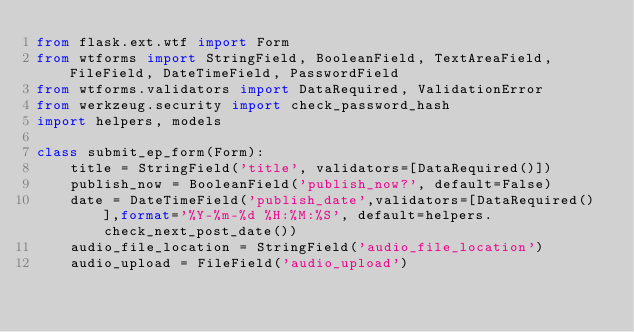Convert code to text. <code><loc_0><loc_0><loc_500><loc_500><_Python_>from flask.ext.wtf import Form
from wtforms import StringField, BooleanField, TextAreaField, FileField, DateTimeField, PasswordField
from wtforms.validators import DataRequired, ValidationError
from werkzeug.security import check_password_hash
import helpers, models

class submit_ep_form(Form):
    title = StringField('title', validators=[DataRequired()])
    publish_now = BooleanField('publish_now?', default=False)
    date = DateTimeField('publish_date',validators=[DataRequired()],format='%Y-%m-%d %H:%M:%S', default=helpers.check_next_post_date())
    audio_file_location = StringField('audio_file_location')
    audio_upload = FileField('audio_upload')</code> 